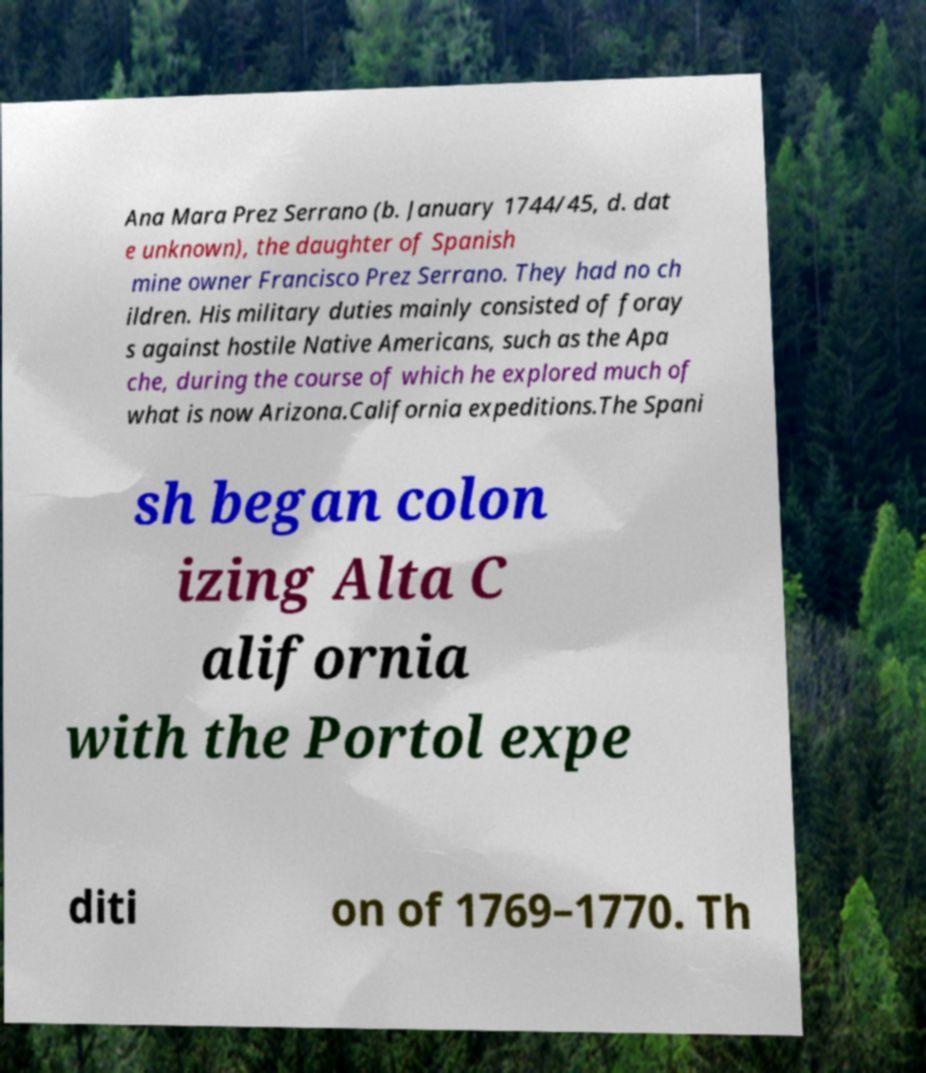Could you assist in decoding the text presented in this image and type it out clearly? Ana Mara Prez Serrano (b. January 1744/45, d. dat e unknown), the daughter of Spanish mine owner Francisco Prez Serrano. They had no ch ildren. His military duties mainly consisted of foray s against hostile Native Americans, such as the Apa che, during the course of which he explored much of what is now Arizona.California expeditions.The Spani sh began colon izing Alta C alifornia with the Portol expe diti on of 1769–1770. Th 